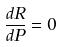Convert formula to latex. <formula><loc_0><loc_0><loc_500><loc_500>\frac { d R } { d P } = 0</formula> 